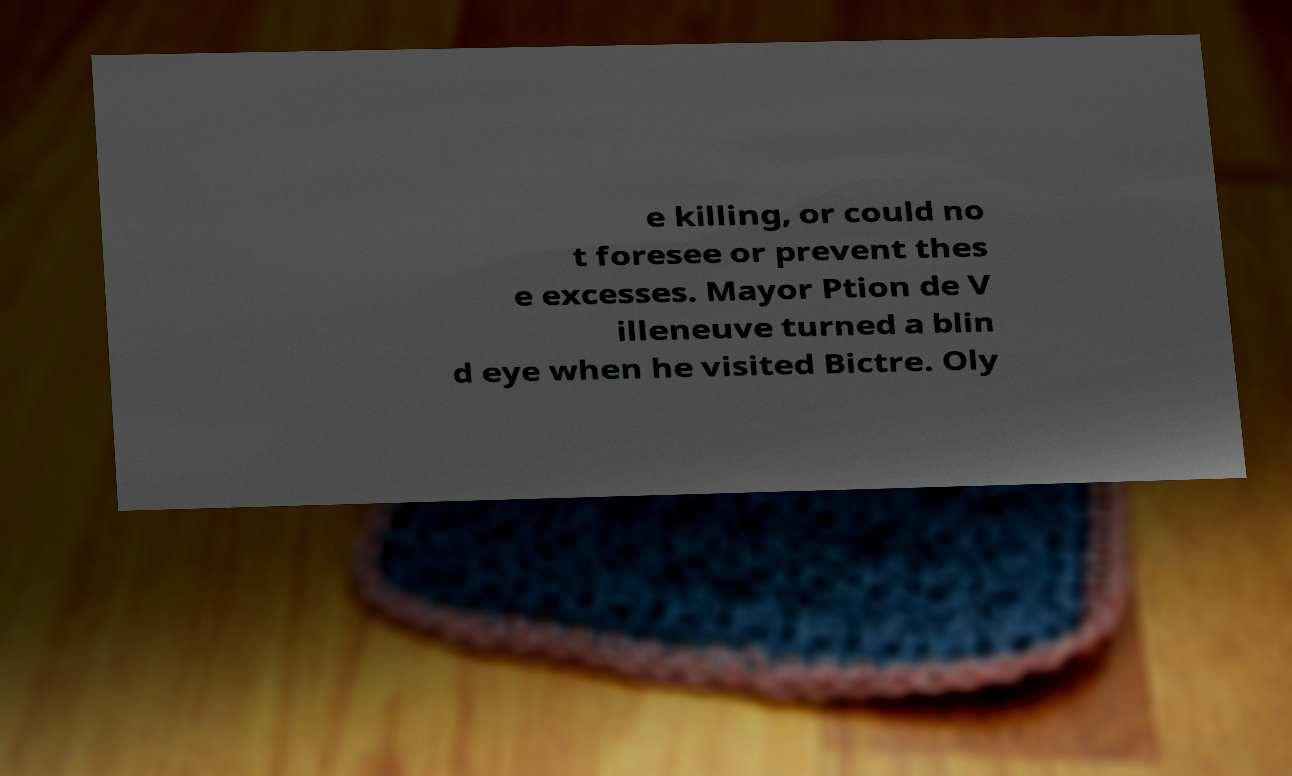What messages or text are displayed in this image? I need them in a readable, typed format. e killing, or could no t foresee or prevent thes e excesses. Mayor Ption de V illeneuve turned a blin d eye when he visited Bictre. Oly 